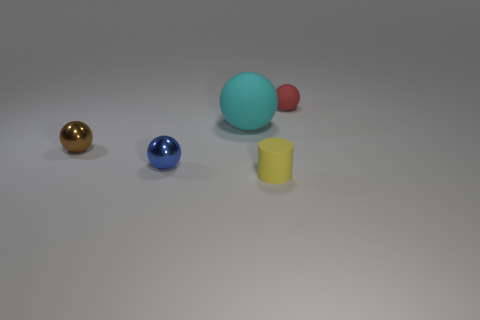There is a sphere behind the big cyan thing; does it have the same size as the blue thing that is to the left of the yellow rubber cylinder?
Ensure brevity in your answer.  Yes. What number of things are purple metal objects or things behind the tiny brown thing?
Ensure brevity in your answer.  2. Is there a small red object of the same shape as the small brown thing?
Provide a short and direct response. Yes. There is a metal object behind the metal thing that is in front of the brown object; how big is it?
Provide a succinct answer. Small. Do the big thing and the cylinder have the same color?
Your answer should be compact. No. How many metal objects are blue objects or small cylinders?
Ensure brevity in your answer.  1. How many tiny spheres are there?
Keep it short and to the point. 3. Does the object that is right of the tiny yellow object have the same material as the thing that is in front of the tiny blue ball?
Offer a very short reply. Yes. There is a tiny rubber thing that is the same shape as the big object; what is its color?
Provide a succinct answer. Red. The ball that is in front of the small brown metallic thing that is on the left side of the cyan thing is made of what material?
Provide a short and direct response. Metal. 